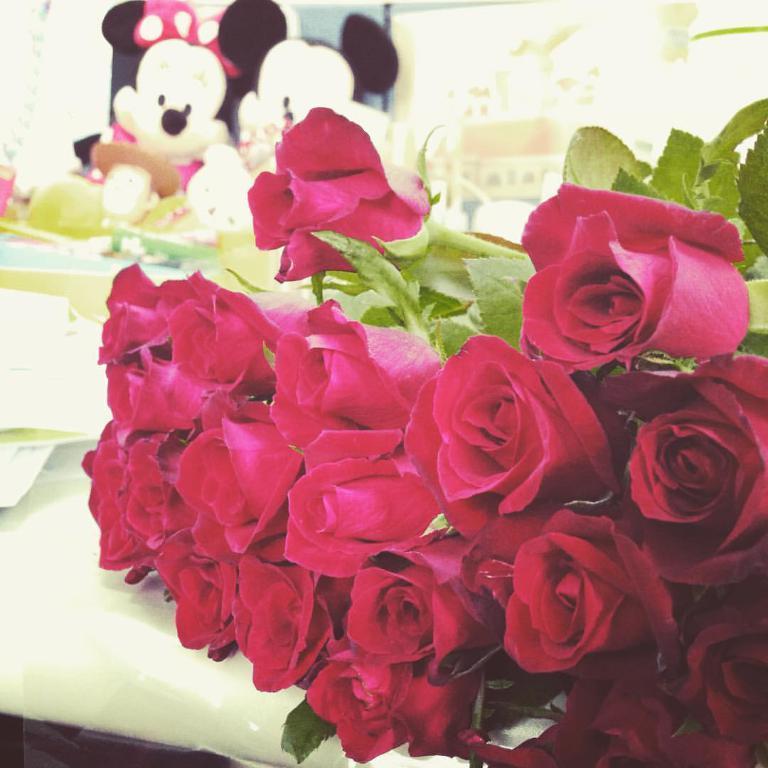Please provide a concise description of this image. In this picture we can see red roses on the table, beside that we can see papers. At the top there are two toys near to window. Through the window we can see the building. 